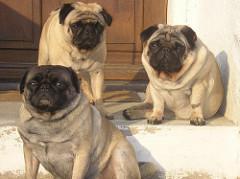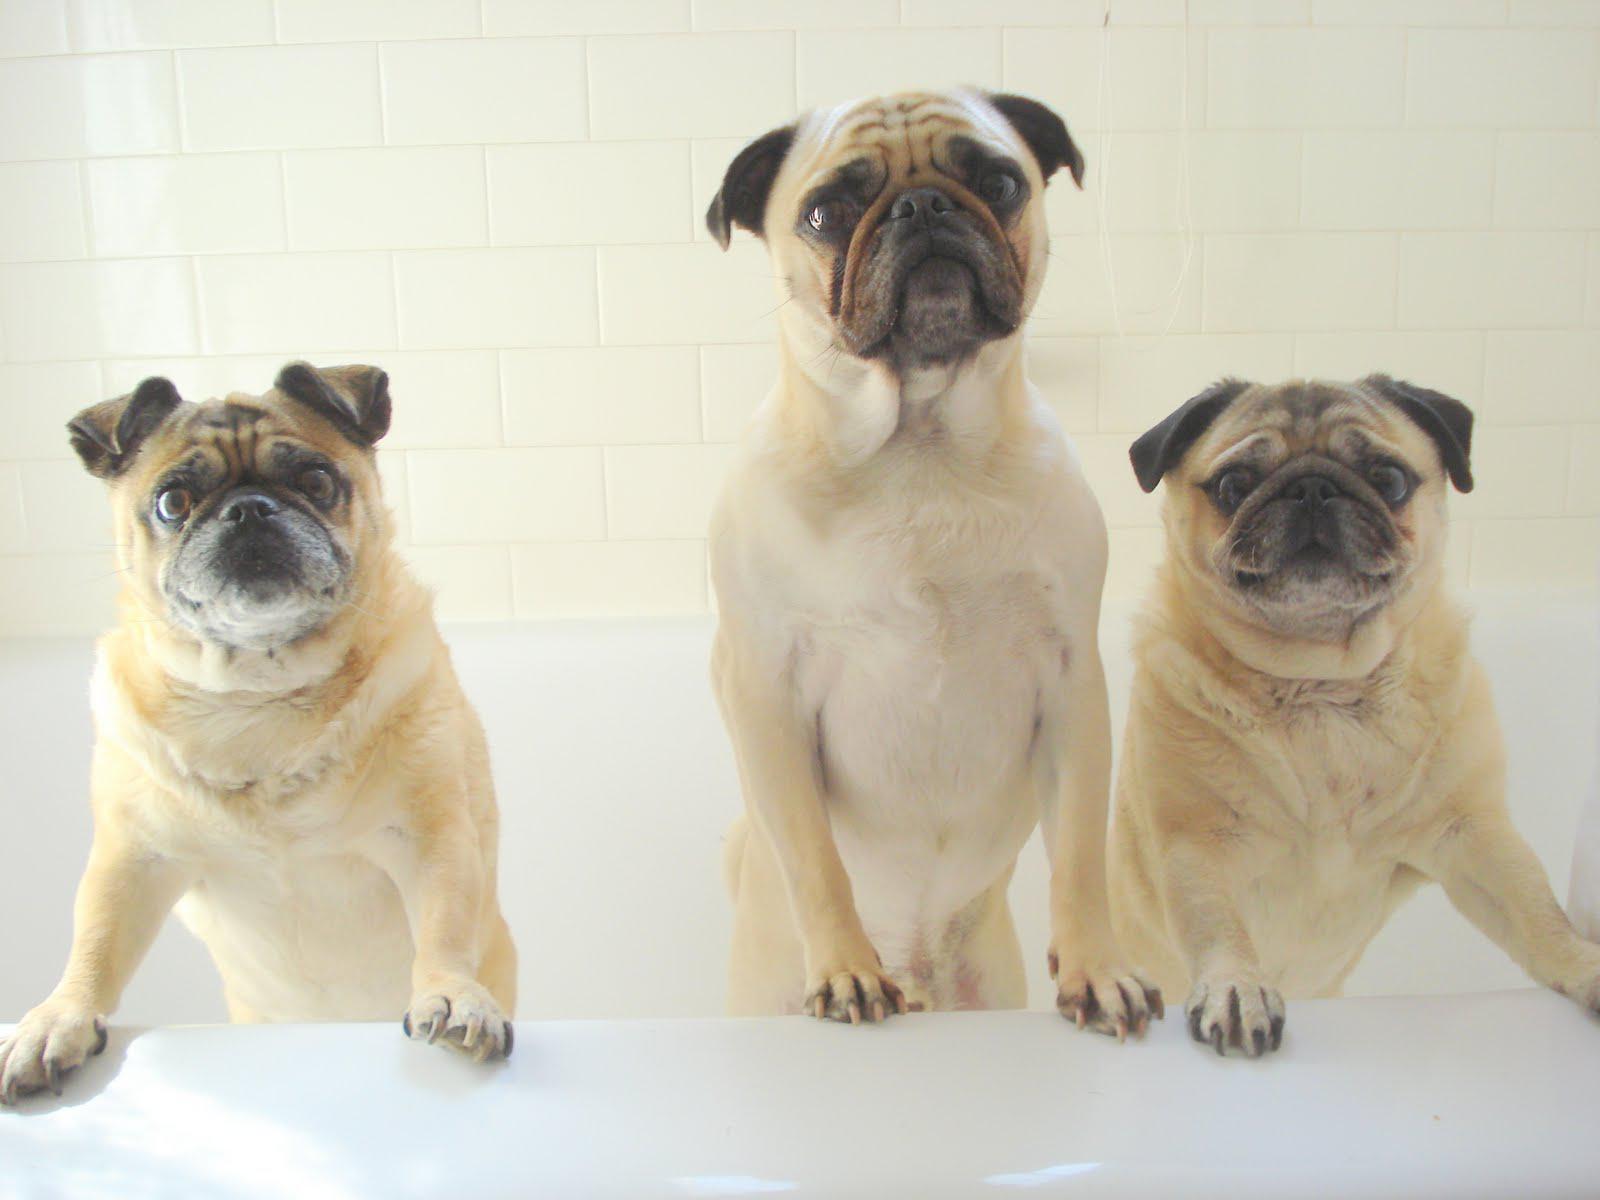The first image is the image on the left, the second image is the image on the right. Evaluate the accuracy of this statement regarding the images: "Three dogs have their front paws off the ground.". Is it true? Answer yes or no. Yes. The first image is the image on the left, the second image is the image on the right. Assess this claim about the two images: "One image shows a trio of pugs snoozing on a beige cushioned item, and the other image shows a row of three pugs, with paws draped on something white.". Correct or not? Answer yes or no. No. 